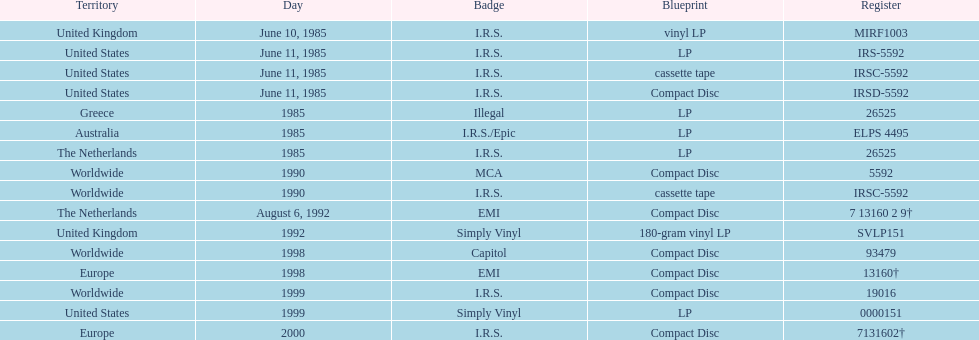On which date did the first vinyl lp make its debut? June 10, 1985. 